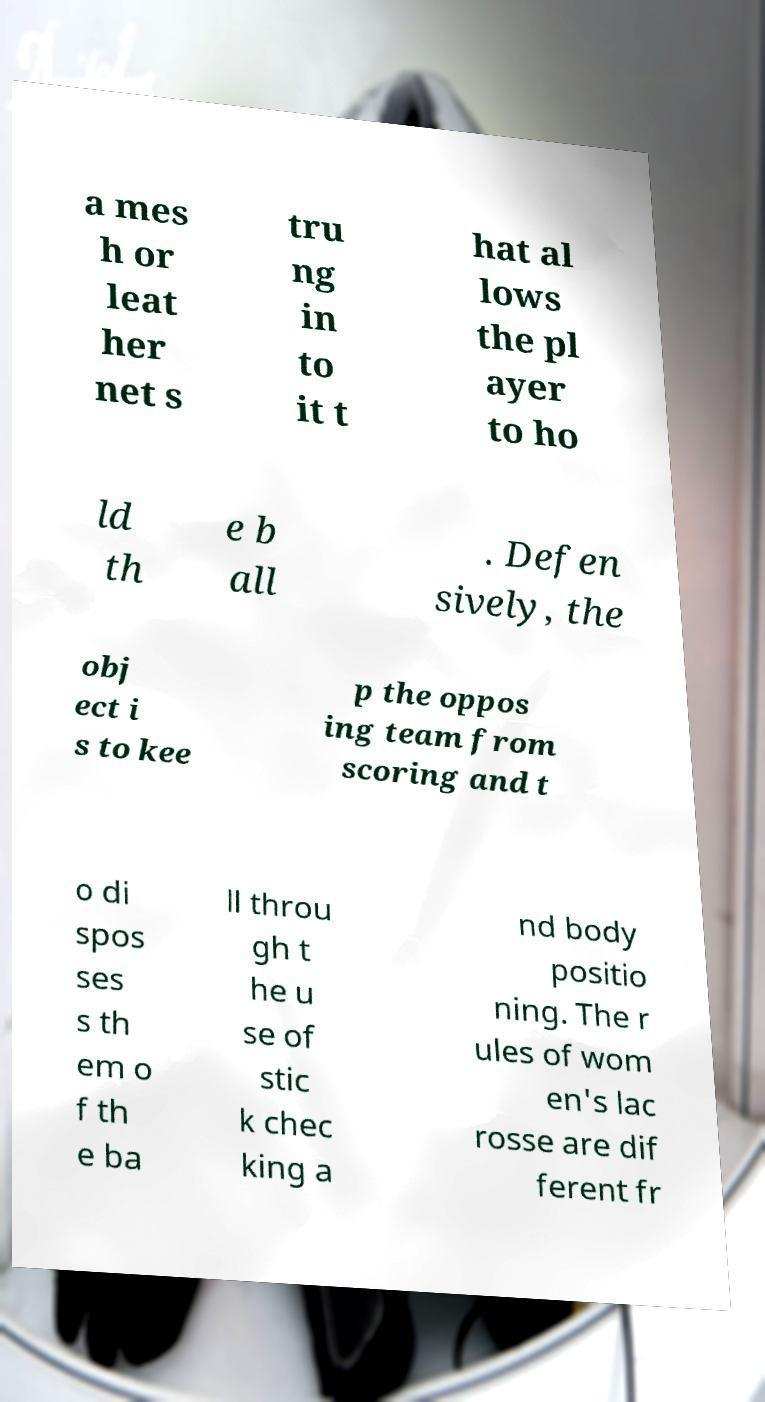I need the written content from this picture converted into text. Can you do that? a mes h or leat her net s tru ng in to it t hat al lows the pl ayer to ho ld th e b all . Defen sively, the obj ect i s to kee p the oppos ing team from scoring and t o di spos ses s th em o f th e ba ll throu gh t he u se of stic k chec king a nd body positio ning. The r ules of wom en's lac rosse are dif ferent fr 